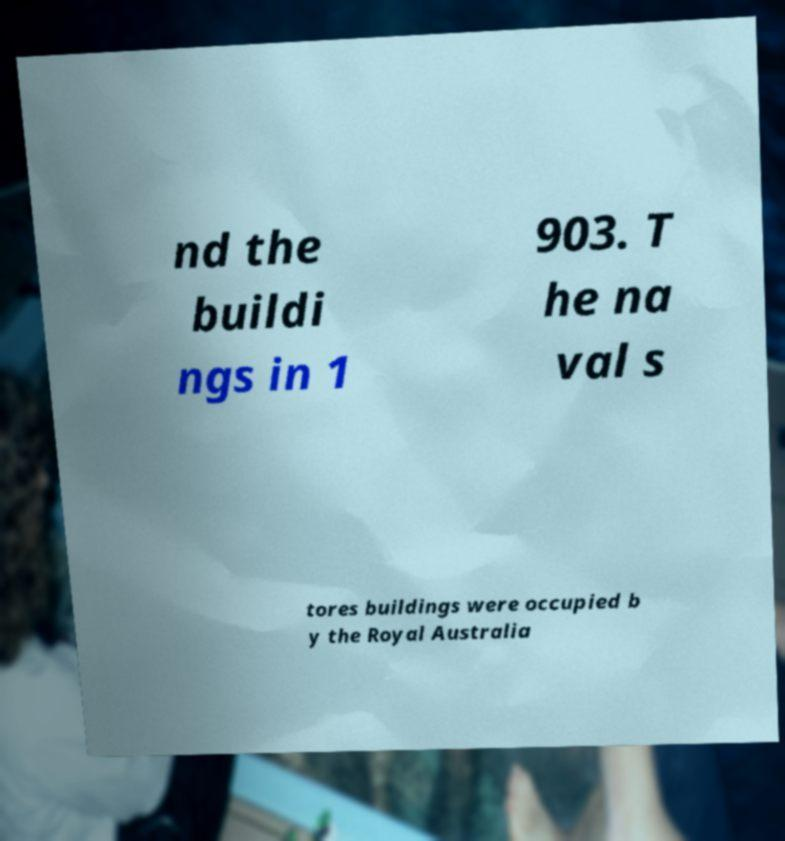Can you read and provide the text displayed in the image?This photo seems to have some interesting text. Can you extract and type it out for me? nd the buildi ngs in 1 903. T he na val s tores buildings were occupied b y the Royal Australia 